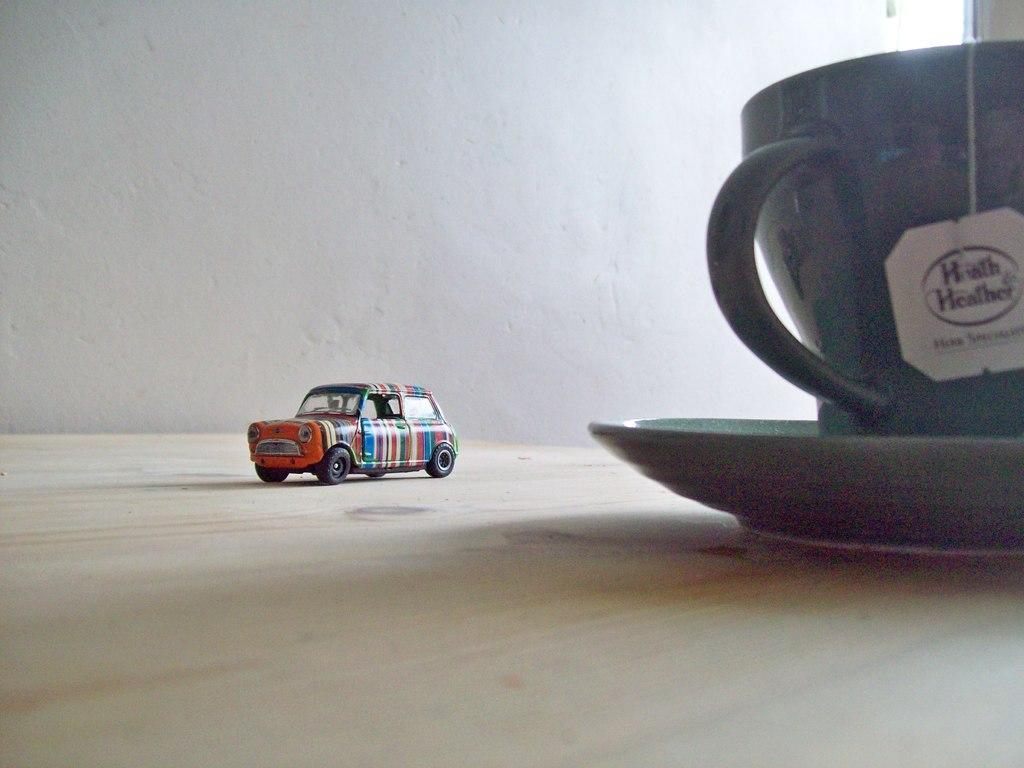In one or two sentences, can you explain what this image depicts? In this image we can see toy of a car, cup and saucer placed on the table. In the background there is wall. 